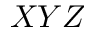<formula> <loc_0><loc_0><loc_500><loc_500>X Y Z</formula> 